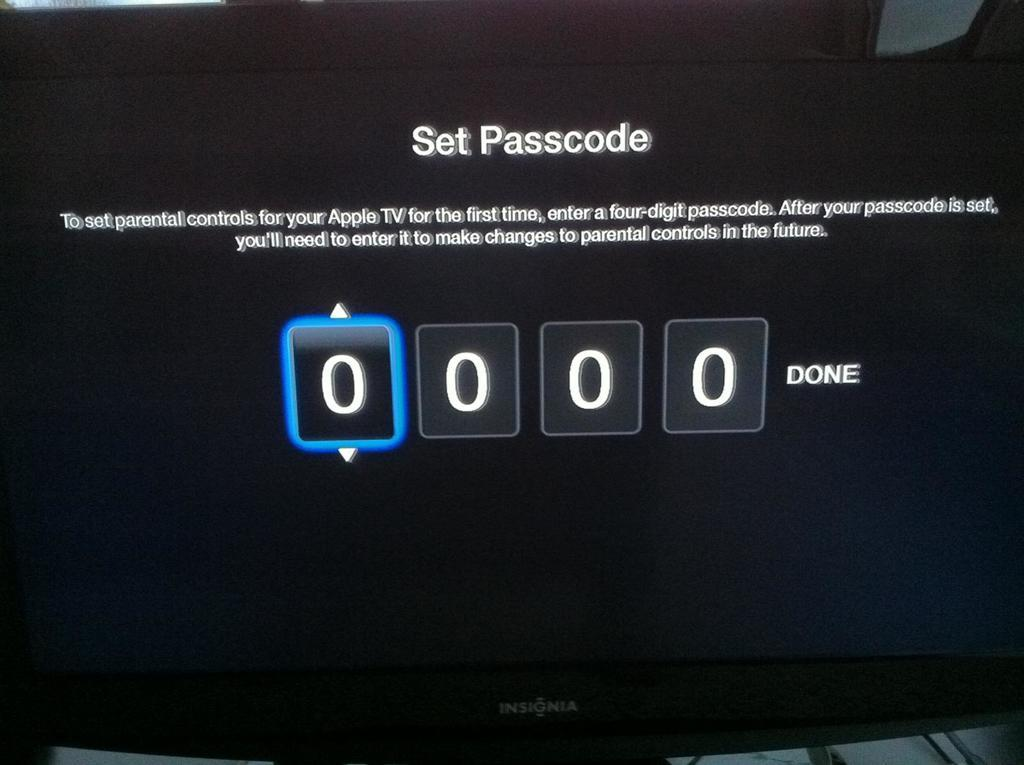<image>
Summarize the visual content of the image. A screen has a set passcode displayed.with four number fields. 